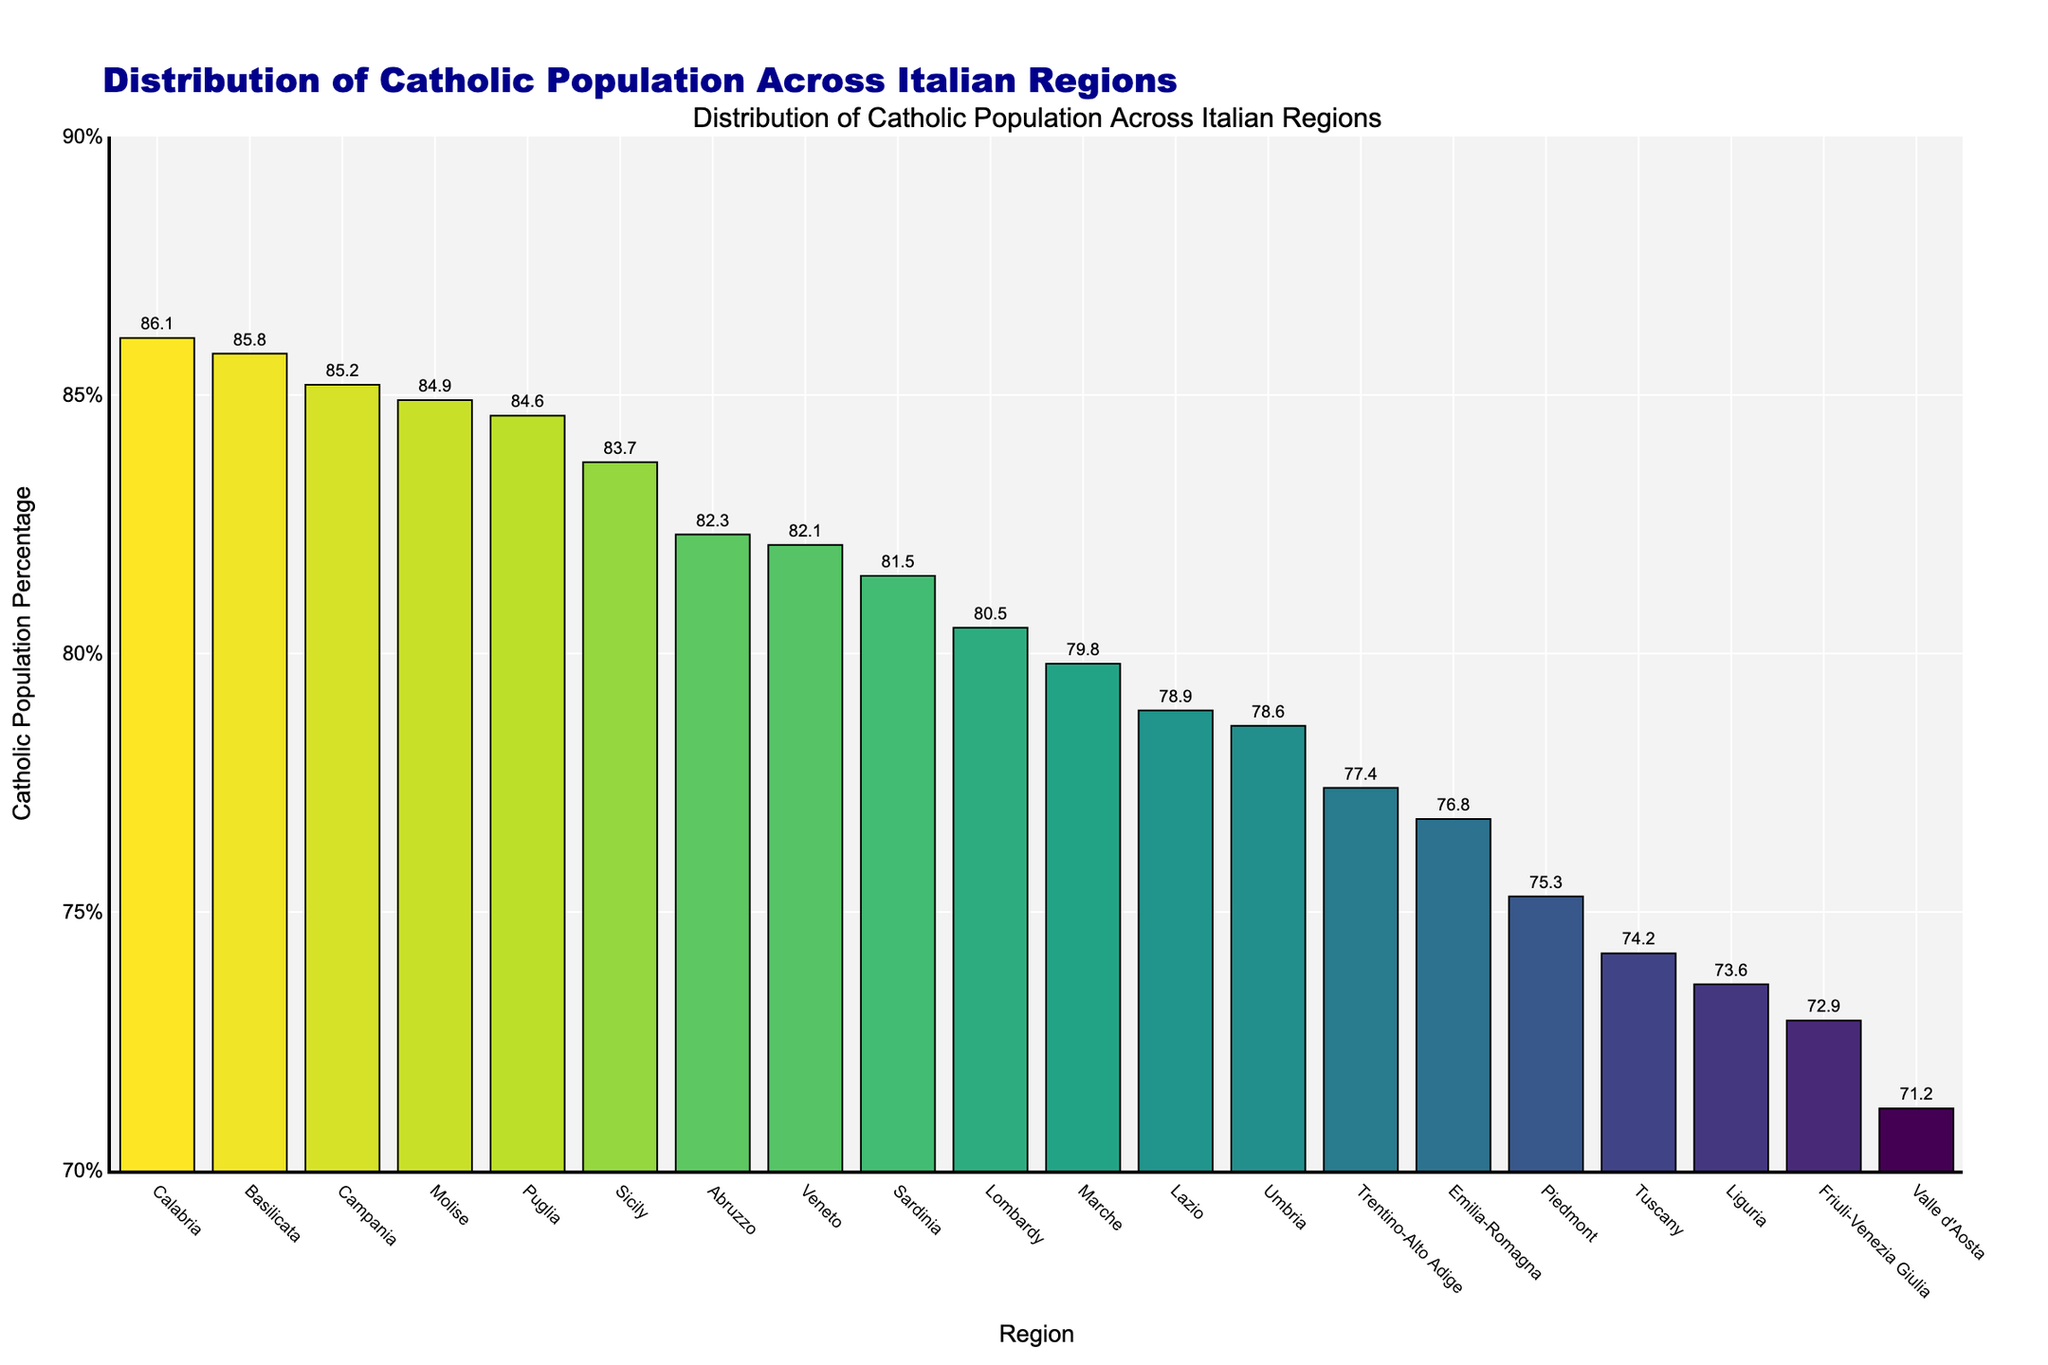What is the region with the highest percentage of the Catholic population? The highest bar represents the region with the highest percentage. By observing the figure, the highest bar is for Calabria.
Answer: Calabria Which region has a lower Catholic population percentage, Tuscany or Liguria? Locate the bars for Tuscany and Liguria. Tuscany's bar is slightly higher than Liguria's, indicating Tuscany has a higher percentage, making Liguria the lower one.
Answer: Liguria What is the difference in Catholic population percentage between Lombardy and Lazio? Find the bars for Lombardy and Lazio. Lombardy has 80.5% and Lazio has 78.9%. Subtract the smaller percentage from the larger: 80.5% - 78.9% = 1.6%.
Answer: 1.6% How many regions have a Catholic population percentage above 80%? Count the number of bars exceeding the 80% mark. Regions with bars above 80% are Lombardy, Campania, Sicily, Veneto, Puglia, Calabria, Sardinia, Abruzzo, Basilicata, Molise. This makes it a total of 10 regions.
Answer: 10 Which region has the lowest percentage of the Catholic population? The shortest bar indicates the region with the lowest percentage, which is Valle d'Aosta.
Answer: Valle d'Aosta Is the Catholic population percentage in Emilia-Romagna higher or lower than in Trentino-Alto Adige? Compare the heights of the bars. Emilia-Romagna's bar is slightly lower than Trentino-Alto Adige's, indicating it’s lower.
Answer: Lower Calculate the average Catholic population percentage for Tuscany and Umbria. Locate the bars for Tuscany and Umbria. Add their values: 74.2% + 78.6% = 152.8%. Divide by 2 to get the average: 152.8% / 2 = 76.4%.
Answer: 76.4% Which region has a Catholic population percentage closest to 80%? Identify the bar closest to the 80% line. Marche has a percentage of 79.8%, which is closest to 80%.
Answer: Marche What is the range of Catholic population percentages across all regions? Find the highest and the lowest values. Calabria has the highest at 86.1% and Valle d'Aosta has the lowest at 71.2%. Subtract the lowest from the highest: 86.1% - 71.2% = 14.9%.
Answer: 14.9% Does Friuli-Venezia Giulia have a higher or lower Catholic population percentage than the average of Sardinia and Liguria? Find the average of Sardinia (81.5%) and Liguria (73.6%): (81.5% + 73.6%) / 2 = 77.55%. Friuli-Venezia Giulia has 72.9%, which is lower than 77.55%.
Answer: Lower 